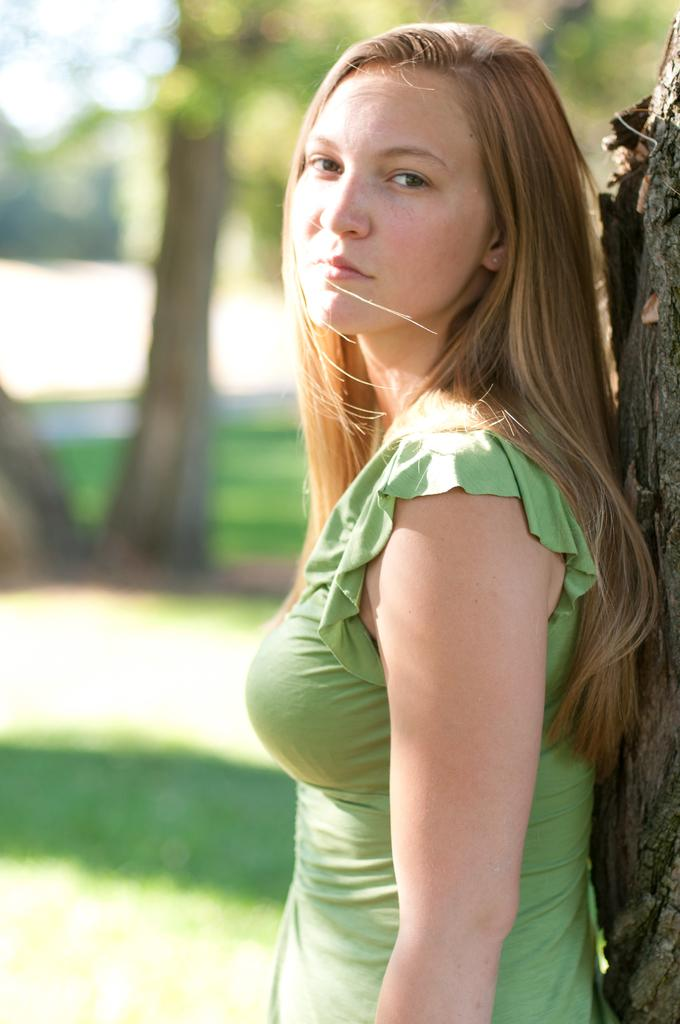What is the main subject in the image? There is a person standing in the image. Can you describe any specific details about the person? Unfortunately, the provided facts do not mention any specific details about the person. What can be seen in the right corner of the image? There is tree bark in the right corner of the image. What type of vegetation is visible at the bottom of the image? It appears that there is grass at the bottom of the image. What is visible in the background of the image? There are trees in the background of the image. What type of toothpaste is being used by the person in the image? There is no toothpaste present in the image, as it features a person standing with tree bark, grass, and trees in the background. 